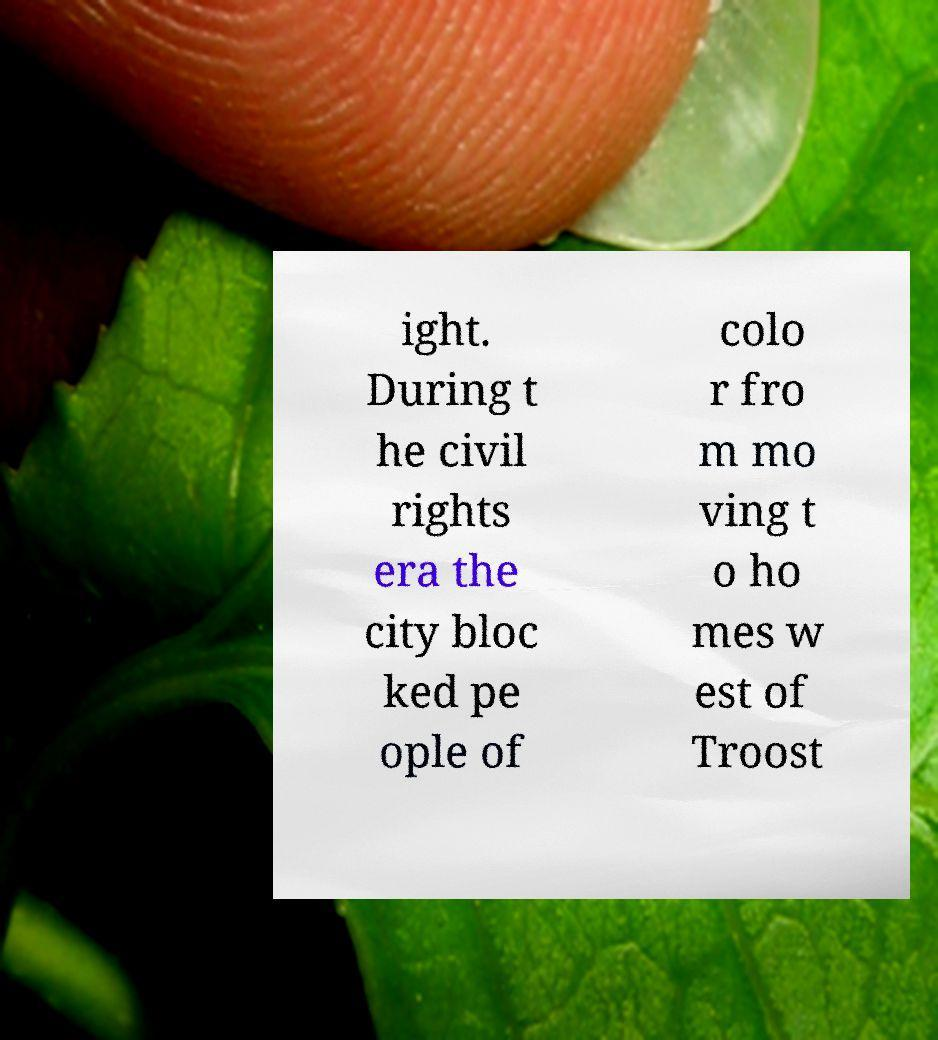There's text embedded in this image that I need extracted. Can you transcribe it verbatim? ight. During t he civil rights era the city bloc ked pe ople of colo r fro m mo ving t o ho mes w est of Troost 